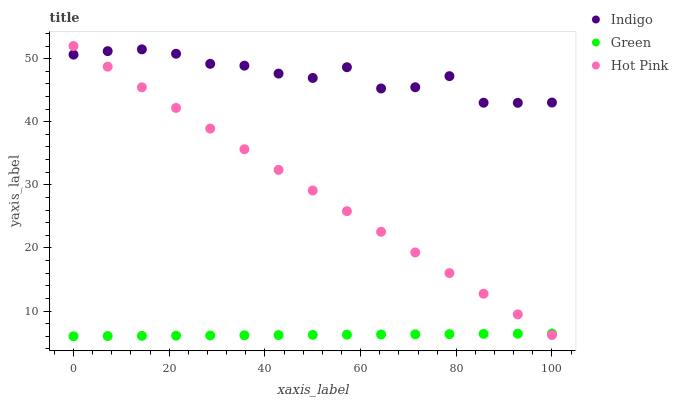Does Green have the minimum area under the curve?
Answer yes or no. Yes. Does Indigo have the maximum area under the curve?
Answer yes or no. Yes. Does Hot Pink have the minimum area under the curve?
Answer yes or no. No. Does Hot Pink have the maximum area under the curve?
Answer yes or no. No. Is Green the smoothest?
Answer yes or no. Yes. Is Indigo the roughest?
Answer yes or no. Yes. Is Hot Pink the smoothest?
Answer yes or no. No. Is Hot Pink the roughest?
Answer yes or no. No. Does Green have the lowest value?
Answer yes or no. Yes. Does Hot Pink have the lowest value?
Answer yes or no. No. Does Hot Pink have the highest value?
Answer yes or no. Yes. Does Indigo have the highest value?
Answer yes or no. No. Is Green less than Indigo?
Answer yes or no. Yes. Is Indigo greater than Green?
Answer yes or no. Yes. Does Green intersect Hot Pink?
Answer yes or no. Yes. Is Green less than Hot Pink?
Answer yes or no. No. Is Green greater than Hot Pink?
Answer yes or no. No. Does Green intersect Indigo?
Answer yes or no. No. 